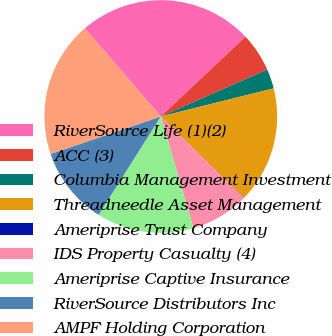<chart> <loc_0><loc_0><loc_500><loc_500><pie_chart><fcel>RiverSource Life (1)(2)<fcel>ACC (3)<fcel>Columbia Management Investment<fcel>Threadneedle Asset Management<fcel>Ameriprise Trust Company<fcel>IDS Property Casualty (4)<fcel>Ameriprise Captive Insurance<fcel>RiverSource Distributors Inc<fcel>AMPF Holding Corporation<nl><fcel>24.29%<fcel>5.42%<fcel>2.72%<fcel>16.2%<fcel>0.03%<fcel>8.12%<fcel>13.51%<fcel>10.81%<fcel>18.9%<nl></chart> 